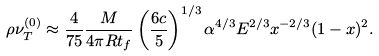Convert formula to latex. <formula><loc_0><loc_0><loc_500><loc_500>\rho \nu _ { T } ^ { ( 0 ) } \approx \frac { 4 } { 7 5 } \frac { M } { 4 \pi R t _ { f } } \left ( \frac { 6 c } { 5 } \right ) ^ { 1 / 3 } \alpha ^ { 4 / 3 } E ^ { 2 / 3 } x ^ { - 2 / 3 } ( 1 - x ) ^ { 2 } .</formula> 